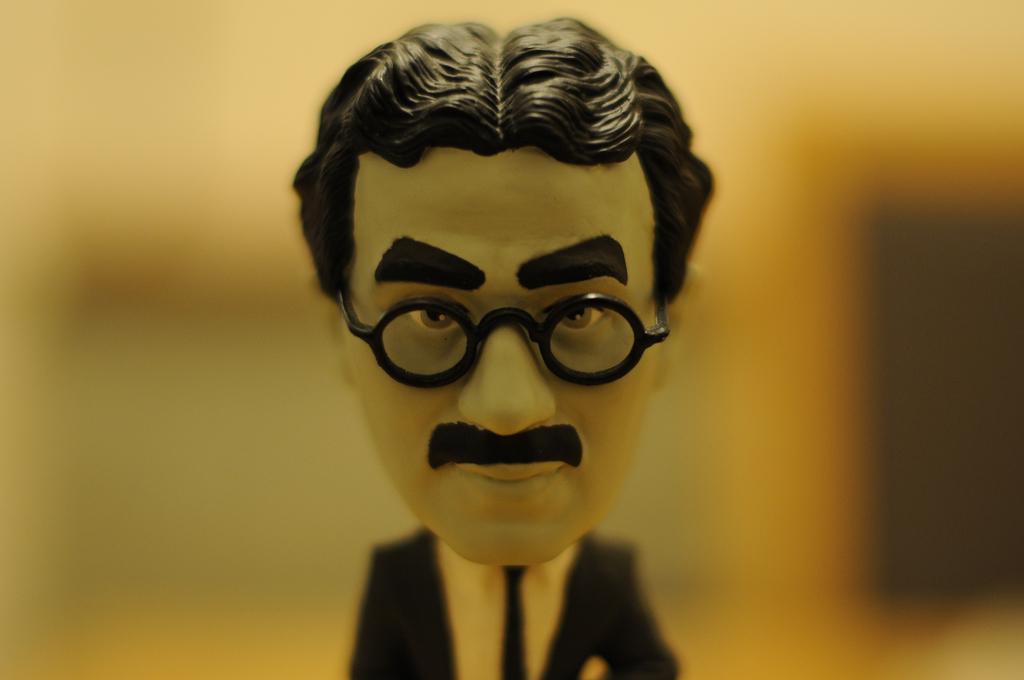Please provide a concise description of this image. In the picture we can see a doll of a man with optical, mustache, black blazer, tie and white shirt and behind the doll it is not clearly visible. 